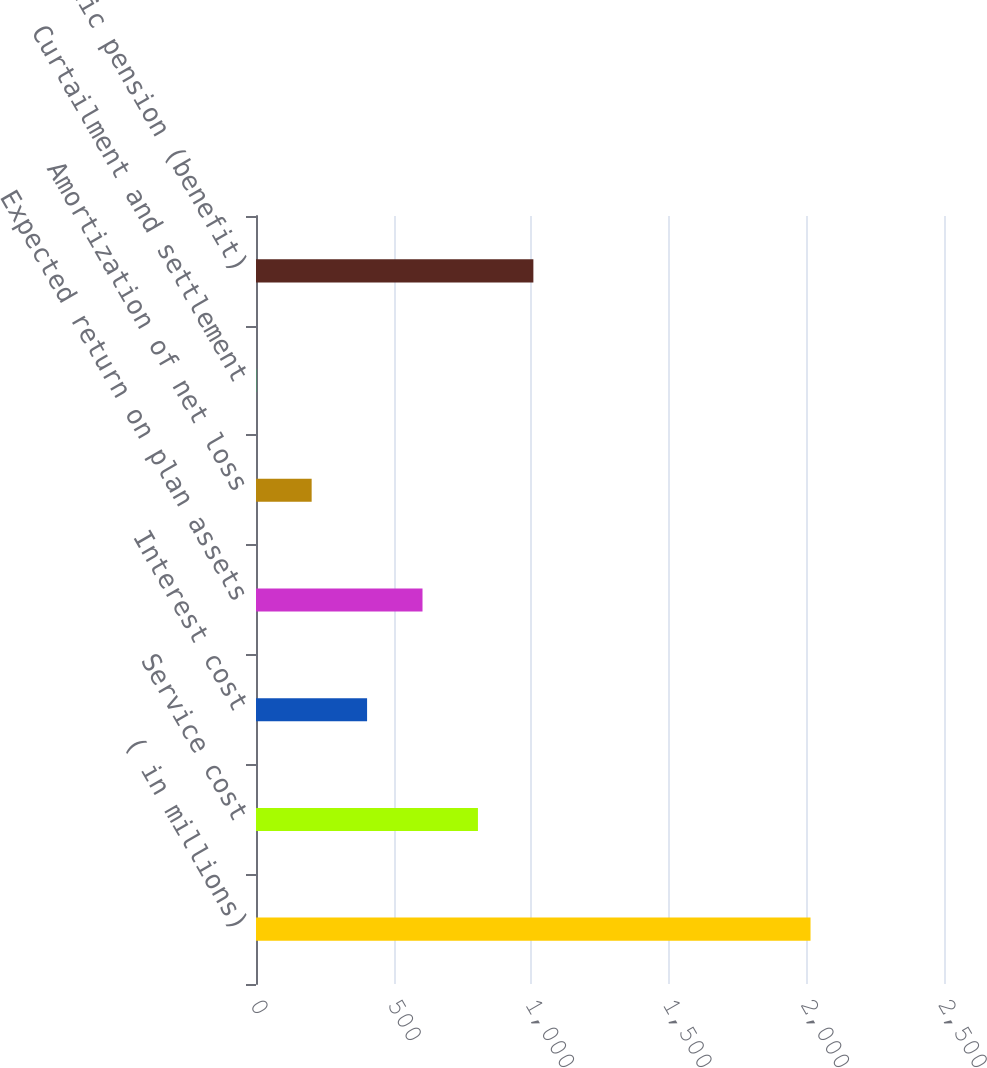Convert chart to OTSL. <chart><loc_0><loc_0><loc_500><loc_500><bar_chart><fcel>( in millions)<fcel>Service cost<fcel>Interest cost<fcel>Expected return on plan assets<fcel>Amortization of net loss<fcel>Curtailment and settlement<fcel>Net periodic pension (benefit)<nl><fcel>2015<fcel>806.48<fcel>403.64<fcel>605.06<fcel>202.22<fcel>0.8<fcel>1007.9<nl></chart> 